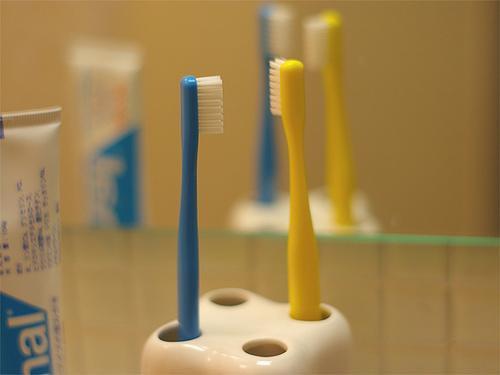How many toothbrushes are there?
Give a very brief answer. 2. 